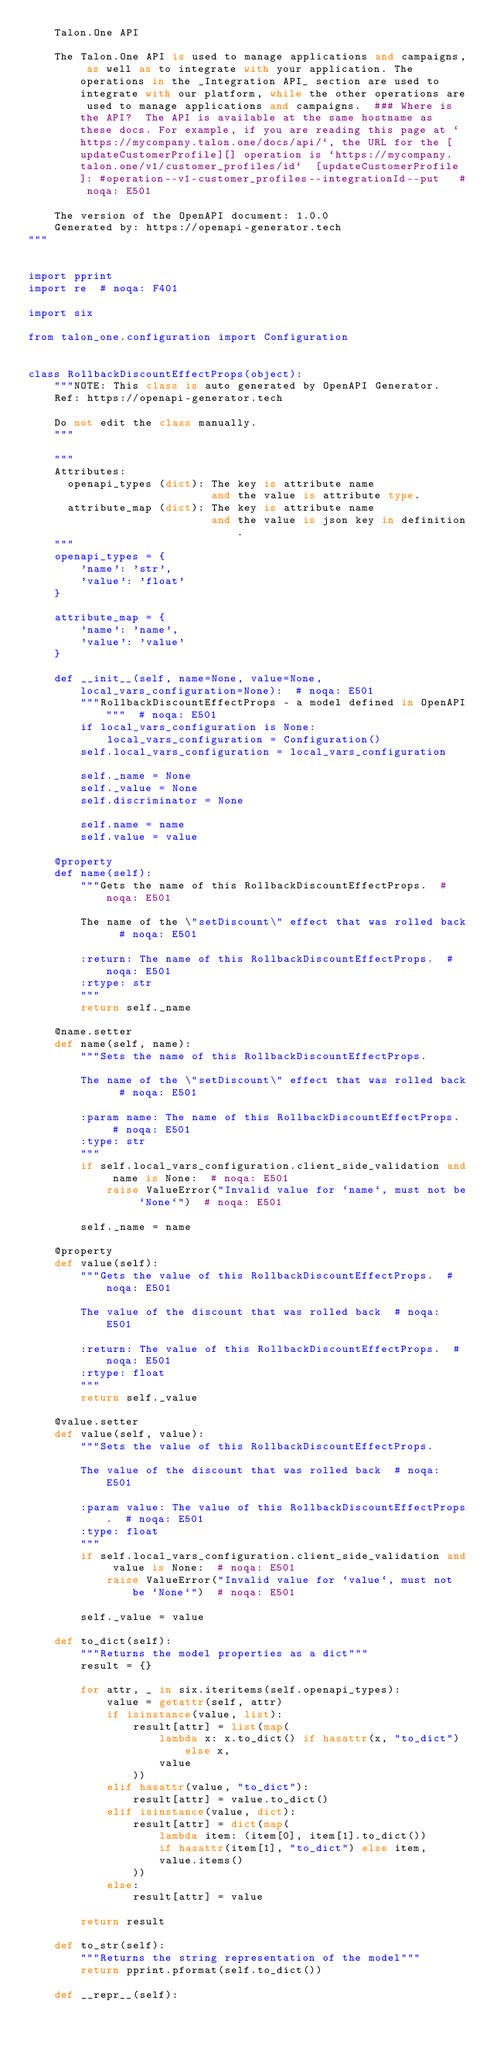<code> <loc_0><loc_0><loc_500><loc_500><_Python_>    Talon.One API

    The Talon.One API is used to manage applications and campaigns, as well as to integrate with your application. The operations in the _Integration API_ section are used to integrate with our platform, while the other operations are used to manage applications and campaigns.  ### Where is the API?  The API is available at the same hostname as these docs. For example, if you are reading this page at `https://mycompany.talon.one/docs/api/`, the URL for the [updateCustomerProfile][] operation is `https://mycompany.talon.one/v1/customer_profiles/id`  [updateCustomerProfile]: #operation--v1-customer_profiles--integrationId--put   # noqa: E501

    The version of the OpenAPI document: 1.0.0
    Generated by: https://openapi-generator.tech
"""


import pprint
import re  # noqa: F401

import six

from talon_one.configuration import Configuration


class RollbackDiscountEffectProps(object):
    """NOTE: This class is auto generated by OpenAPI Generator.
    Ref: https://openapi-generator.tech

    Do not edit the class manually.
    """

    """
    Attributes:
      openapi_types (dict): The key is attribute name
                            and the value is attribute type.
      attribute_map (dict): The key is attribute name
                            and the value is json key in definition.
    """
    openapi_types = {
        'name': 'str',
        'value': 'float'
    }

    attribute_map = {
        'name': 'name',
        'value': 'value'
    }

    def __init__(self, name=None, value=None, local_vars_configuration=None):  # noqa: E501
        """RollbackDiscountEffectProps - a model defined in OpenAPI"""  # noqa: E501
        if local_vars_configuration is None:
            local_vars_configuration = Configuration()
        self.local_vars_configuration = local_vars_configuration

        self._name = None
        self._value = None
        self.discriminator = None

        self.name = name
        self.value = value

    @property
    def name(self):
        """Gets the name of this RollbackDiscountEffectProps.  # noqa: E501

        The name of the \"setDiscount\" effect that was rolled back  # noqa: E501

        :return: The name of this RollbackDiscountEffectProps.  # noqa: E501
        :rtype: str
        """
        return self._name

    @name.setter
    def name(self, name):
        """Sets the name of this RollbackDiscountEffectProps.

        The name of the \"setDiscount\" effect that was rolled back  # noqa: E501

        :param name: The name of this RollbackDiscountEffectProps.  # noqa: E501
        :type: str
        """
        if self.local_vars_configuration.client_side_validation and name is None:  # noqa: E501
            raise ValueError("Invalid value for `name`, must not be `None`")  # noqa: E501

        self._name = name

    @property
    def value(self):
        """Gets the value of this RollbackDiscountEffectProps.  # noqa: E501

        The value of the discount that was rolled back  # noqa: E501

        :return: The value of this RollbackDiscountEffectProps.  # noqa: E501
        :rtype: float
        """
        return self._value

    @value.setter
    def value(self, value):
        """Sets the value of this RollbackDiscountEffectProps.

        The value of the discount that was rolled back  # noqa: E501

        :param value: The value of this RollbackDiscountEffectProps.  # noqa: E501
        :type: float
        """
        if self.local_vars_configuration.client_side_validation and value is None:  # noqa: E501
            raise ValueError("Invalid value for `value`, must not be `None`")  # noqa: E501

        self._value = value

    def to_dict(self):
        """Returns the model properties as a dict"""
        result = {}

        for attr, _ in six.iteritems(self.openapi_types):
            value = getattr(self, attr)
            if isinstance(value, list):
                result[attr] = list(map(
                    lambda x: x.to_dict() if hasattr(x, "to_dict") else x,
                    value
                ))
            elif hasattr(value, "to_dict"):
                result[attr] = value.to_dict()
            elif isinstance(value, dict):
                result[attr] = dict(map(
                    lambda item: (item[0], item[1].to_dict())
                    if hasattr(item[1], "to_dict") else item,
                    value.items()
                ))
            else:
                result[attr] = value

        return result

    def to_str(self):
        """Returns the string representation of the model"""
        return pprint.pformat(self.to_dict())

    def __repr__(self):</code> 